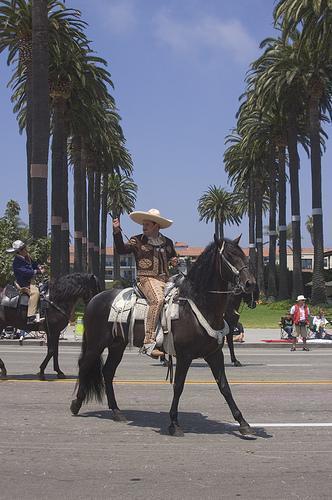What type of hat is the man wearing?
Select the correct answer and articulate reasoning with the following format: 'Answer: answer
Rationale: rationale.'
Options: Baseball, sombrero, fedora, tippy. Answer: sombrero.
Rationale: The man has a sombrero on. 